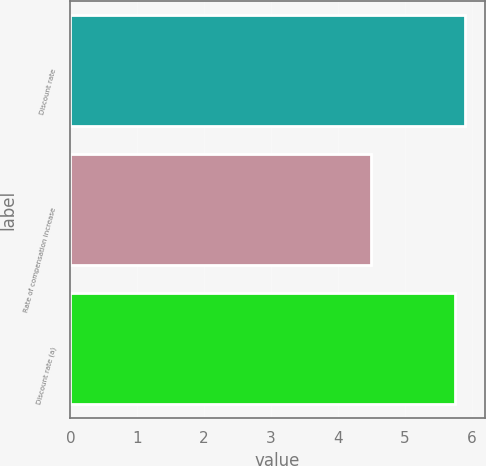Convert chart. <chart><loc_0><loc_0><loc_500><loc_500><bar_chart><fcel>Discount rate<fcel>Rate of compensation increase<fcel>Discount rate (a)<nl><fcel>5.9<fcel>4.5<fcel>5.75<nl></chart> 